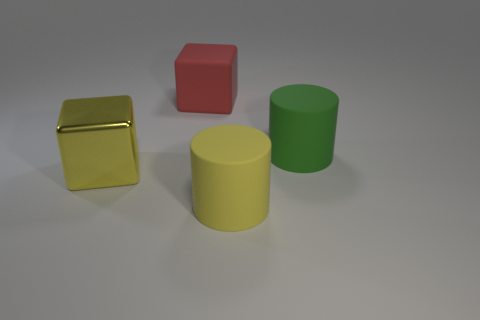Add 1 blue rubber spheres. How many objects exist? 5 Subtract all green cylinders. How many cylinders are left? 1 Subtract 1 cubes. How many cubes are left? 1 Subtract all metallic cubes. Subtract all yellow matte cylinders. How many objects are left? 2 Add 1 shiny objects. How many shiny objects are left? 2 Add 2 small rubber cubes. How many small rubber cubes exist? 2 Subtract 0 gray cubes. How many objects are left? 4 Subtract all red cubes. Subtract all blue balls. How many cubes are left? 1 Subtract all gray balls. How many red cylinders are left? 0 